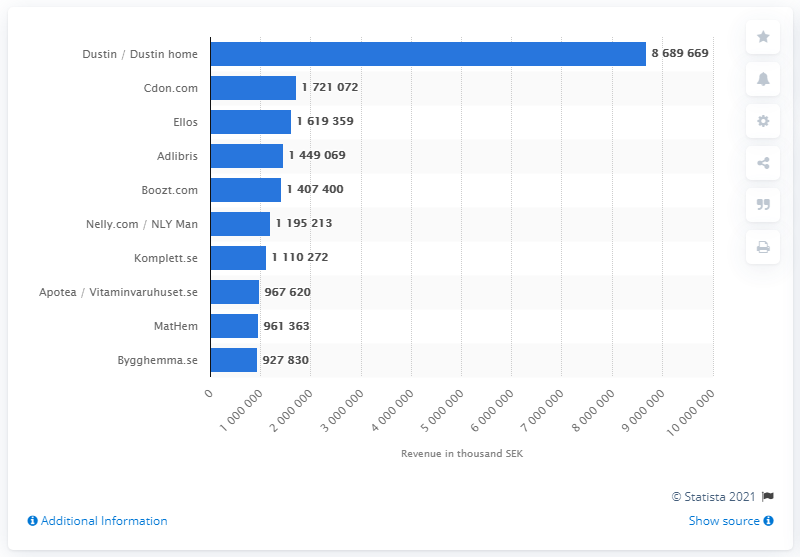Indicate a few pertinent items in this graphic. In 2018, Cdon.com was the second largest web shop in Sweden. 